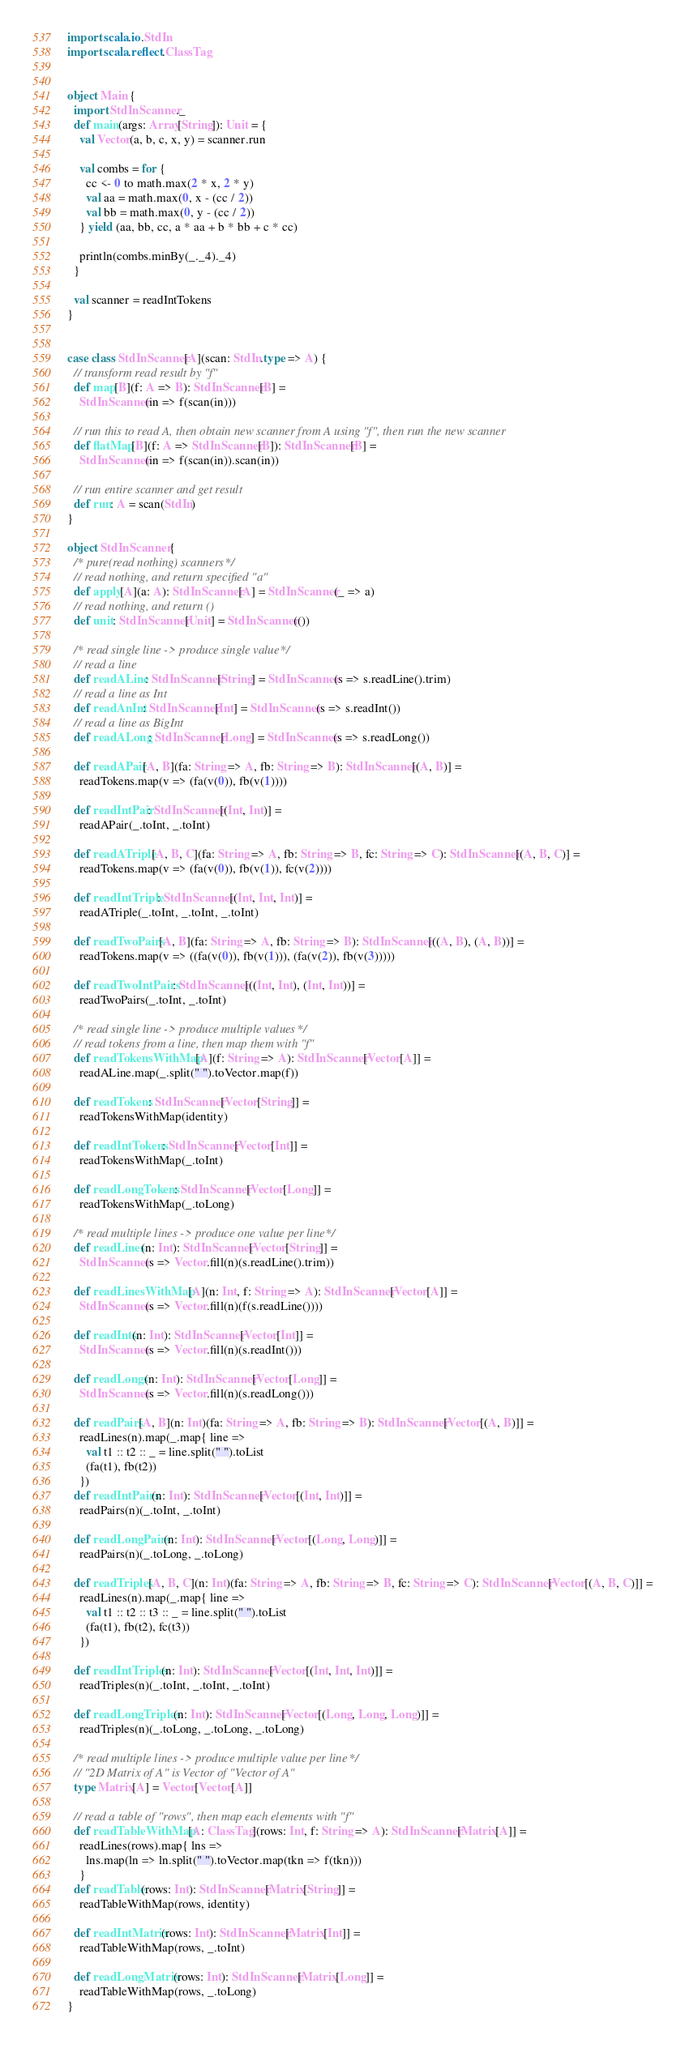<code> <loc_0><loc_0><loc_500><loc_500><_Scala_>

import scala.io.StdIn
import scala.reflect.ClassTag


object Main {
  import StdInScanner._
  def main(args: Array[String]): Unit = {
    val Vector(a, b, c, x, y) = scanner.run

    val combs = for {
      cc <- 0 to math.max(2 * x, 2 * y)
      val aa = math.max(0, x - (cc / 2))
      val bb = math.max(0, y - (cc / 2))
    } yield (aa, bb, cc, a * aa + b * bb + c * cc)

    println(combs.minBy(_._4)._4)
  }

  val scanner = readIntTokens
}


case class StdInScanner[A](scan: StdIn.type => A) {
  // transform read result by "f"
  def map[B](f: A => B): StdInScanner[B] =
    StdInScanner(in => f(scan(in)))

  // run this to read A, then obtain new scanner from A using "f", then run the new scanner
  def flatMap[B](f: A => StdInScanner[B]): StdInScanner[B] =
    StdInScanner(in => f(scan(in)).scan(in))

  // run entire scanner and get result
  def run: A = scan(StdIn)
}

object StdInScanner {
  /* pure(read nothing) scanners */
  // read nothing, and return specified "a"
  def apply[A](a: A): StdInScanner[A] = StdInScanner(_ => a)
  // read nothing, and return ()
  def unit: StdInScanner[Unit] = StdInScanner(())

  /* read single line -> produce single value */
  // read a line
  def readALine: StdInScanner[String] = StdInScanner(s => s.readLine().trim)
  // read a line as Int
  def readAnInt: StdInScanner[Int] = StdInScanner(s => s.readInt())
  // read a line as BigInt
  def readALong: StdInScanner[Long] = StdInScanner(s => s.readLong())

  def readAPair[A, B](fa: String => A, fb: String => B): StdInScanner[(A, B)] =
    readTokens.map(v => (fa(v(0)), fb(v(1))))

  def readIntPair: StdInScanner[(Int, Int)] =
    readAPair(_.toInt, _.toInt)

  def readATriple[A, B, C](fa: String => A, fb: String => B, fc: String => C): StdInScanner[(A, B, C)] =
    readTokens.map(v => (fa(v(0)), fb(v(1)), fc(v(2))))

  def readIntTriple: StdInScanner[(Int, Int, Int)] =
    readATriple(_.toInt, _.toInt, _.toInt)

  def readTwoPairs[A, B](fa: String => A, fb: String => B): StdInScanner[((A, B), (A, B))] =
    readTokens.map(v => ((fa(v(0)), fb(v(1))), (fa(v(2)), fb(v(3)))))

  def readTwoIntPairs: StdInScanner[((Int, Int), (Int, Int))] =
    readTwoPairs(_.toInt, _.toInt)

  /* read single line -> produce multiple values */
  // read tokens from a line, then map them with "f"
  def readTokensWithMap[A](f: String => A): StdInScanner[Vector[A]] =
    readALine.map(_.split(" ").toVector.map(f))

  def readTokens: StdInScanner[Vector[String]] =
    readTokensWithMap(identity)

  def readIntTokens: StdInScanner[Vector[Int]] =
    readTokensWithMap(_.toInt)

  def readLongTokens: StdInScanner[Vector[Long]] =
    readTokensWithMap(_.toLong)

  /* read multiple lines -> produce one value per line */
  def readLines(n: Int): StdInScanner[Vector[String]] =
    StdInScanner(s => Vector.fill(n)(s.readLine().trim))

  def readLinesWithMap[A](n: Int, f: String => A): StdInScanner[Vector[A]] =
    StdInScanner(s => Vector.fill(n)(f(s.readLine())))

  def readInts(n: Int): StdInScanner[Vector[Int]] =
    StdInScanner(s => Vector.fill(n)(s.readInt()))

  def readLongs(n: Int): StdInScanner[Vector[Long]] =
    StdInScanner(s => Vector.fill(n)(s.readLong()))

  def readPairs[A, B](n: Int)(fa: String => A, fb: String => B): StdInScanner[Vector[(A, B)]] =
    readLines(n).map(_.map{ line =>
      val t1 :: t2 :: _ = line.split(" ").toList
      (fa(t1), fb(t2))
    })
  def readIntPairs(n: Int): StdInScanner[Vector[(Int, Int)]] =
    readPairs(n)(_.toInt, _.toInt)

  def readLongPairs(n: Int): StdInScanner[Vector[(Long, Long)]] =
    readPairs(n)(_.toLong, _.toLong)

  def readTriples[A, B, C](n: Int)(fa: String => A, fb: String => B, fc: String => C): StdInScanner[Vector[(A, B, C)]] =
    readLines(n).map(_.map{ line =>
      val t1 :: t2 :: t3 :: _ = line.split(" ").toList
      (fa(t1), fb(t2), fc(t3))
    })

  def readIntTriples(n: Int): StdInScanner[Vector[(Int, Int, Int)]] =
    readTriples(n)(_.toInt, _.toInt, _.toInt)

  def readLongTriples(n: Int): StdInScanner[Vector[(Long, Long, Long)]] =
    readTriples(n)(_.toLong, _.toLong, _.toLong)

  /* read multiple lines -> produce multiple value per line */
  // "2D Matrix of A" is Vector of "Vector of A"
  type Matrix[A] = Vector[Vector[A]]

  // read a table of "rows", then map each elements with "f"
  def readTableWithMap[A: ClassTag](rows: Int, f: String => A): StdInScanner[Matrix[A]] =
    readLines(rows).map{ lns =>
      lns.map(ln => ln.split(" ").toVector.map(tkn => f(tkn)))
    }
  def readTable(rows: Int): StdInScanner[Matrix[String]] =
    readTableWithMap(rows, identity)

  def readIntMatrix(rows: Int): StdInScanner[Matrix[Int]] =
    readTableWithMap(rows, _.toInt)

  def readLongMatrix(rows: Int): StdInScanner[Matrix[Long]] =
    readTableWithMap(rows, _.toLong)
}</code> 